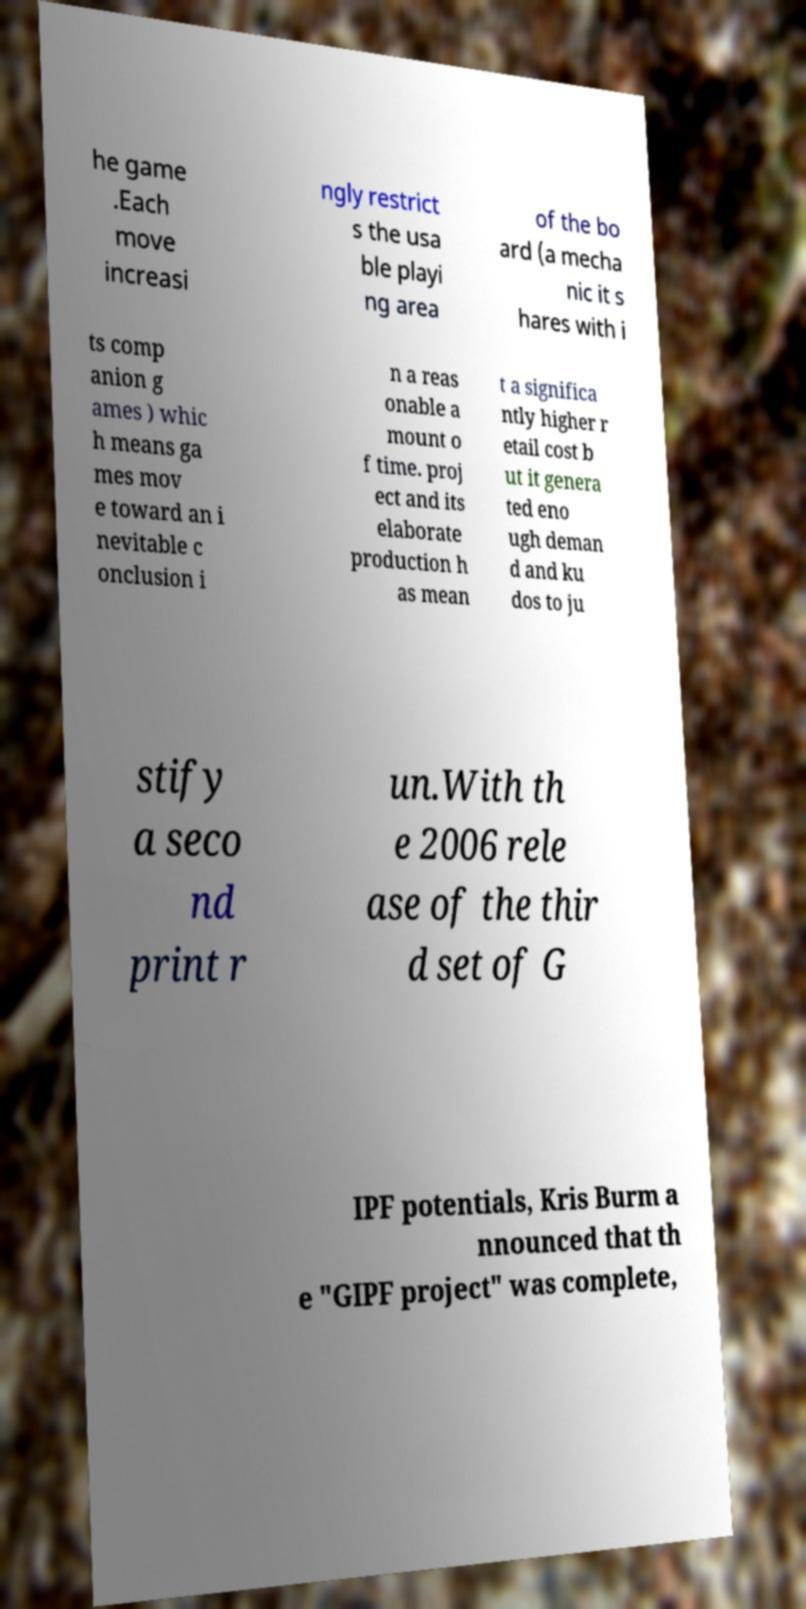I need the written content from this picture converted into text. Can you do that? he game .Each move increasi ngly restrict s the usa ble playi ng area of the bo ard (a mecha nic it s hares with i ts comp anion g ames ) whic h means ga mes mov e toward an i nevitable c onclusion i n a reas onable a mount o f time. proj ect and its elaborate production h as mean t a significa ntly higher r etail cost b ut it genera ted eno ugh deman d and ku dos to ju stify a seco nd print r un.With th e 2006 rele ase of the thir d set of G IPF potentials, Kris Burm a nnounced that th e "GIPF project" was complete, 